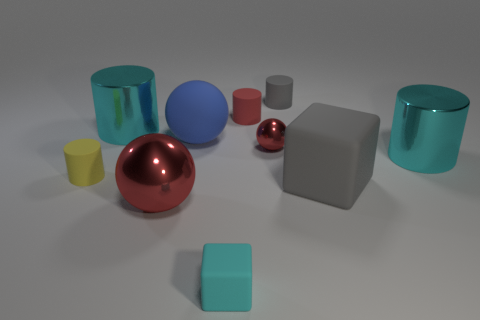How many things are either cyan rubber objects or metallic cylinders that are to the left of the small cyan rubber object?
Give a very brief answer. 2. Is the number of brown things greater than the number of rubber things?
Provide a short and direct response. No. The tiny red metal object that is behind the cyan block has what shape?
Your answer should be compact. Sphere. How many other rubber objects are the same shape as the big red thing?
Ensure brevity in your answer.  1. What is the size of the shiny thing in front of the big matte object in front of the small shiny object?
Offer a very short reply. Large. What number of cyan things are matte cubes or large objects?
Offer a terse response. 3. Is the number of large cyan things in front of the blue matte ball less than the number of tiny cyan blocks to the right of the cyan cube?
Keep it short and to the point. No. Do the yellow cylinder and the blue matte object left of the small red metallic ball have the same size?
Your answer should be compact. No. What number of yellow objects have the same size as the cyan matte cube?
Keep it short and to the point. 1. What number of big things are blue rubber spheres or shiny cylinders?
Provide a succinct answer. 3. 